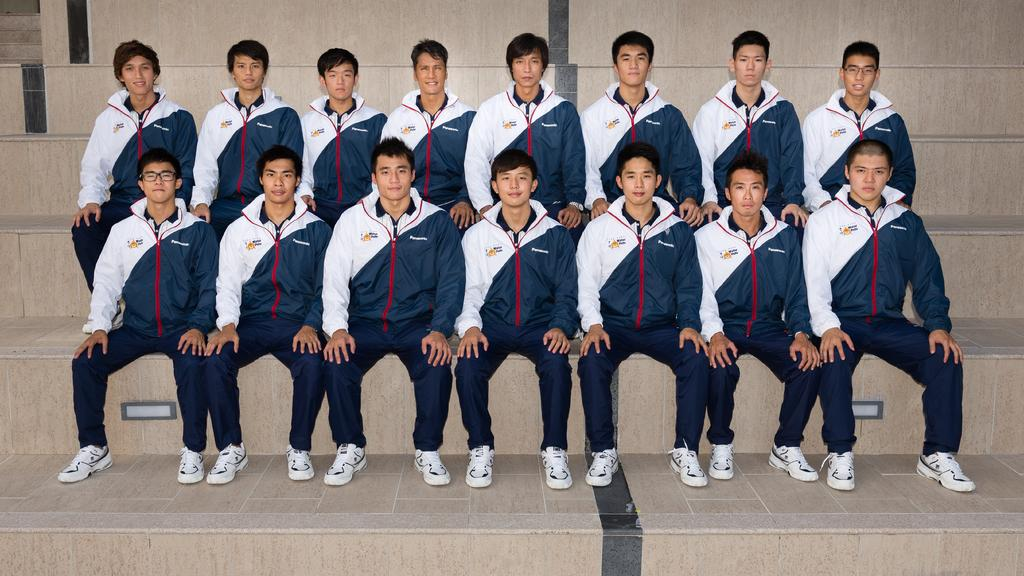What is the main subject of the image? The main subject of the image is a group of men. What are the men doing in the image? The men are sitting in the image. What is the facial expression of the men? The men are smiling in the image. What type of furniture is present in the image? Chairs are present in the image. What type of tooth is visible in the image? There is no tooth visible in the image. What type of shirt is the man wearing in the image? The men are wearing jerkins, not shirts, in the image. 